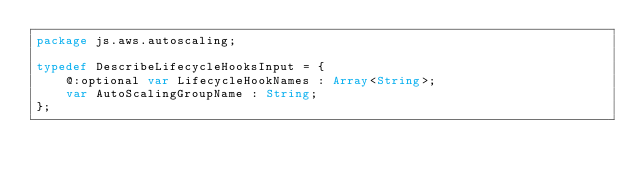<code> <loc_0><loc_0><loc_500><loc_500><_Haxe_>package js.aws.autoscaling;

typedef DescribeLifecycleHooksInput = {
    @:optional var LifecycleHookNames : Array<String>;
    var AutoScalingGroupName : String;
};
</code> 